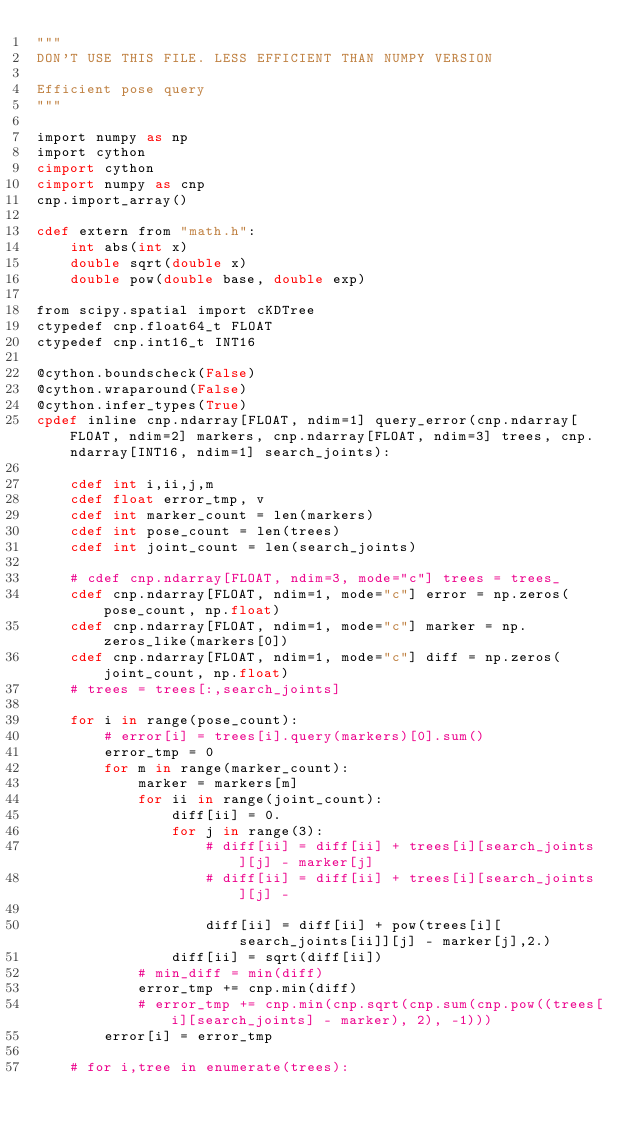<code> <loc_0><loc_0><loc_500><loc_500><_Cython_>"""
DON'T USE THIS FILE. LESS EFFICIENT THAN NUMPY VERSION

Efficient pose query
"""

import numpy as np
import cython
cimport cython
cimport numpy as cnp
cnp.import_array()

cdef extern from "math.h":
	int abs(int x)
	double sqrt(double x)
	double pow(double base, double exp)

from scipy.spatial import cKDTree
ctypedef cnp.float64_t FLOAT
ctypedef cnp.int16_t INT16

@cython.boundscheck(False)
@cython.wraparound(False)
@cython.infer_types(True)
cpdef inline cnp.ndarray[FLOAT, ndim=1] query_error(cnp.ndarray[FLOAT, ndim=2] markers, cnp.ndarray[FLOAT, ndim=3] trees, cnp.ndarray[INT16, ndim=1] search_joints):

	cdef int i,ii,j,m
	cdef float error_tmp, v
	cdef int marker_count = len(markers)
	cdef int pose_count = len(trees)
	cdef int joint_count = len(search_joints)

	# cdef cnp.ndarray[FLOAT, ndim=3, mode="c"] trees = trees_
	cdef cnp.ndarray[FLOAT, ndim=1, mode="c"] error = np.zeros(pose_count, np.float)
	cdef cnp.ndarray[FLOAT, ndim=1, mode="c"] marker = np.zeros_like(markers[0])
	cdef cnp.ndarray[FLOAT, ndim=1, mode="c"] diff = np.zeros(joint_count, np.float)
	# trees = trees[:,search_joints]

	for i in range(pose_count):
		# error[i] = trees[i].query(markers)[0].sum()
		error_tmp = 0
		for m in range(marker_count):
			marker = markers[m]
			for ii in range(joint_count):
				diff[ii] = 0.
				for j in range(3):
					# diff[ii] = diff[ii] + trees[i][search_joints][j] - marker[j]
					# diff[ii] = diff[ii] + trees[i][search_joints][j] -

					diff[ii] = diff[ii] + pow(trees[i][search_joints[ii]][j] - marker[j],2.)
				diff[ii] = sqrt(diff[ii])
			# min_diff = min(diff)
			error_tmp += cnp.min(diff)
			# error_tmp += cnp.min(cnp.sqrt(cnp.sum(cnp.pow((trees[i][search_joints] - marker), 2), -1)))
		error[i] = error_tmp

	# for i,tree in enumerate(trees):</code> 